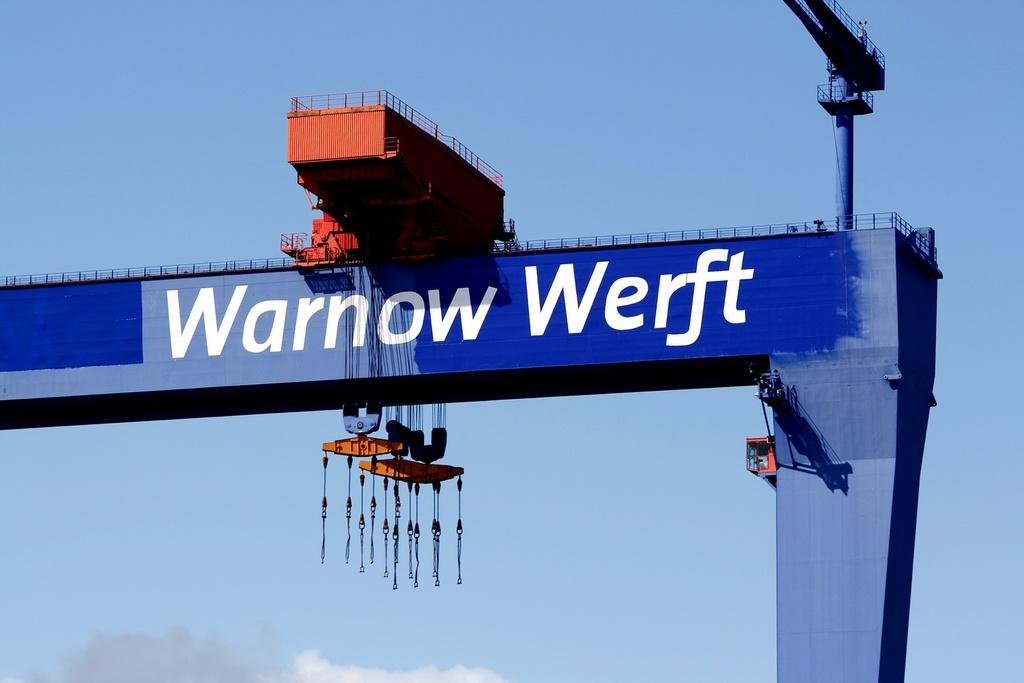<image>
Give a short and clear explanation of the subsequent image. the words warnow werft that is on a long object 